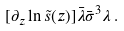<formula> <loc_0><loc_0><loc_500><loc_500>[ \partial _ { z } \ln \tilde { s } ( z ) ] \bar { \lambda } \bar { \sigma } ^ { 3 } \lambda \, .</formula> 